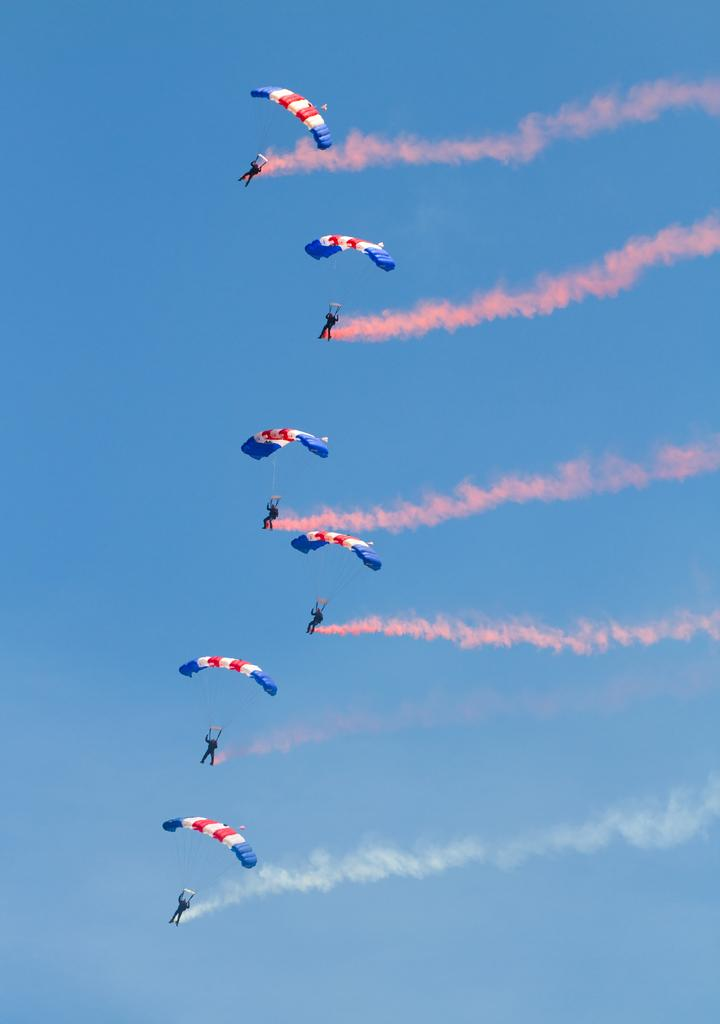What objects are visible in the image that are used for descending from a height? There are parachutes in the image. What are the persons doing in relation to the parachutes? Persons are hanging through the parachutes. Where are the parachutes and persons located in the image? The parachutes and persons are visible in the air. What can be seen in the background of the image? The sky is visible in the image. What type of beds can be seen in the image? There are no beds present in the image. What level of respect is shown towards the parachutes in the image? The image does not convey a level of respect or any opinions about the parachutes. 